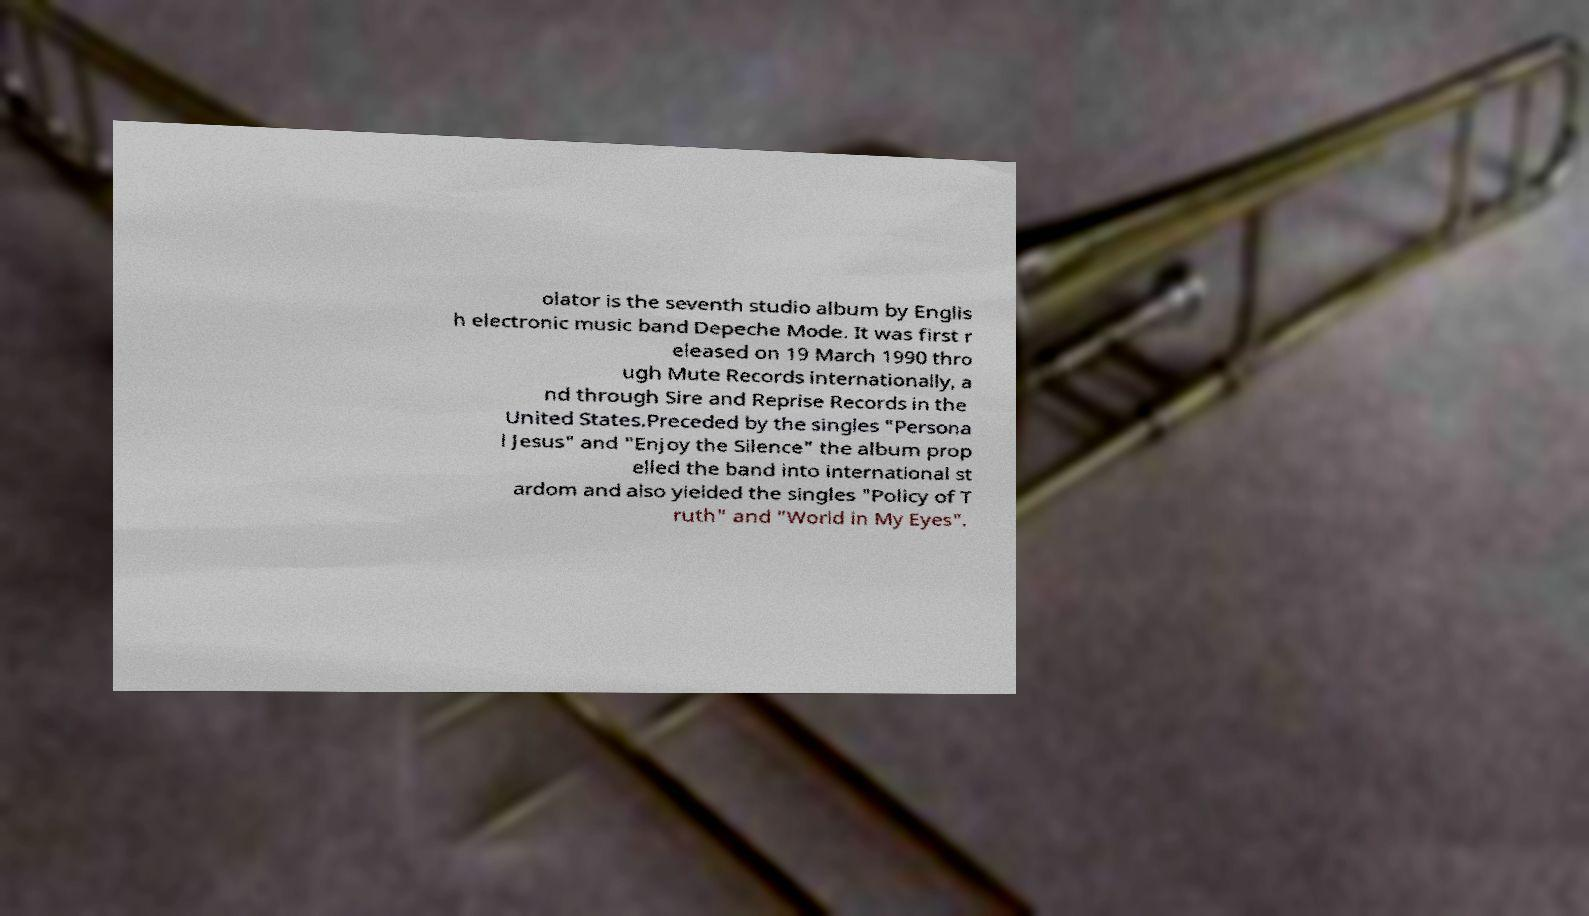For documentation purposes, I need the text within this image transcribed. Could you provide that? olator is the seventh studio album by Englis h electronic music band Depeche Mode. It was first r eleased on 19 March 1990 thro ugh Mute Records internationally, a nd through Sire and Reprise Records in the United States.Preceded by the singles "Persona l Jesus" and "Enjoy the Silence" the album prop elled the band into international st ardom and also yielded the singles "Policy of T ruth" and "World in My Eyes". 